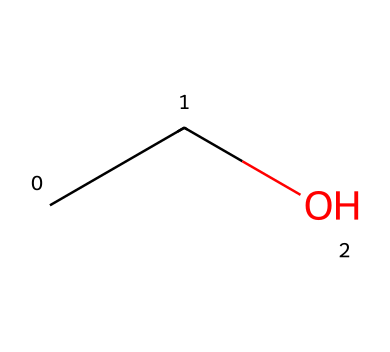How many carbon atoms are in the chemical structure? The SMILES representation "CCO" indicates two carbon atoms ('C' represents a carbon atom), so counting gives you a total of two.
Answer: 2 What type of bonding is present in the structure? In the chemical "CCO", carbon (C) forms single bonds with each other and with oxygen (O). This means the structure primarily involves sigma bonds.
Answer: single bonds What is the molecular formula of the chemical? The SMILES "CCO" translates to the molecular formula C2H6O, which includes 2 carbon atoms (C), 6 hydrogen atoms (H), and 1 oxygen atom (O).
Answer: C2H6O What is the primary functional group in this chemical? The "O" in the structure indicates the presence of an alcohol functional group (-OH), which makes it a key identifying feature of the structure.
Answer: alcohol What is the expected state of this chemical at room temperature? Given that this chemical is ethanol (based on the structure), and knowing that alcohols are typically liquids at room temperature, we can deduce the state.
Answer: liquid How many hydrogen atoms are bonded to the carbon atoms in this molecule? In the structure "CCO", each carbon atom is bonded to enough hydrogen atoms to satisfy the tetravalency of carbon, resulting in 6 hydrogen atoms in total.
Answer: 6 What implication does this structure have on the polarity of the solvent? The presence of an -OH group (alcohol functional group) suggests that the solvent is polar due to the electronegative oxygen atom causing a dipole moment.
Answer: polar 